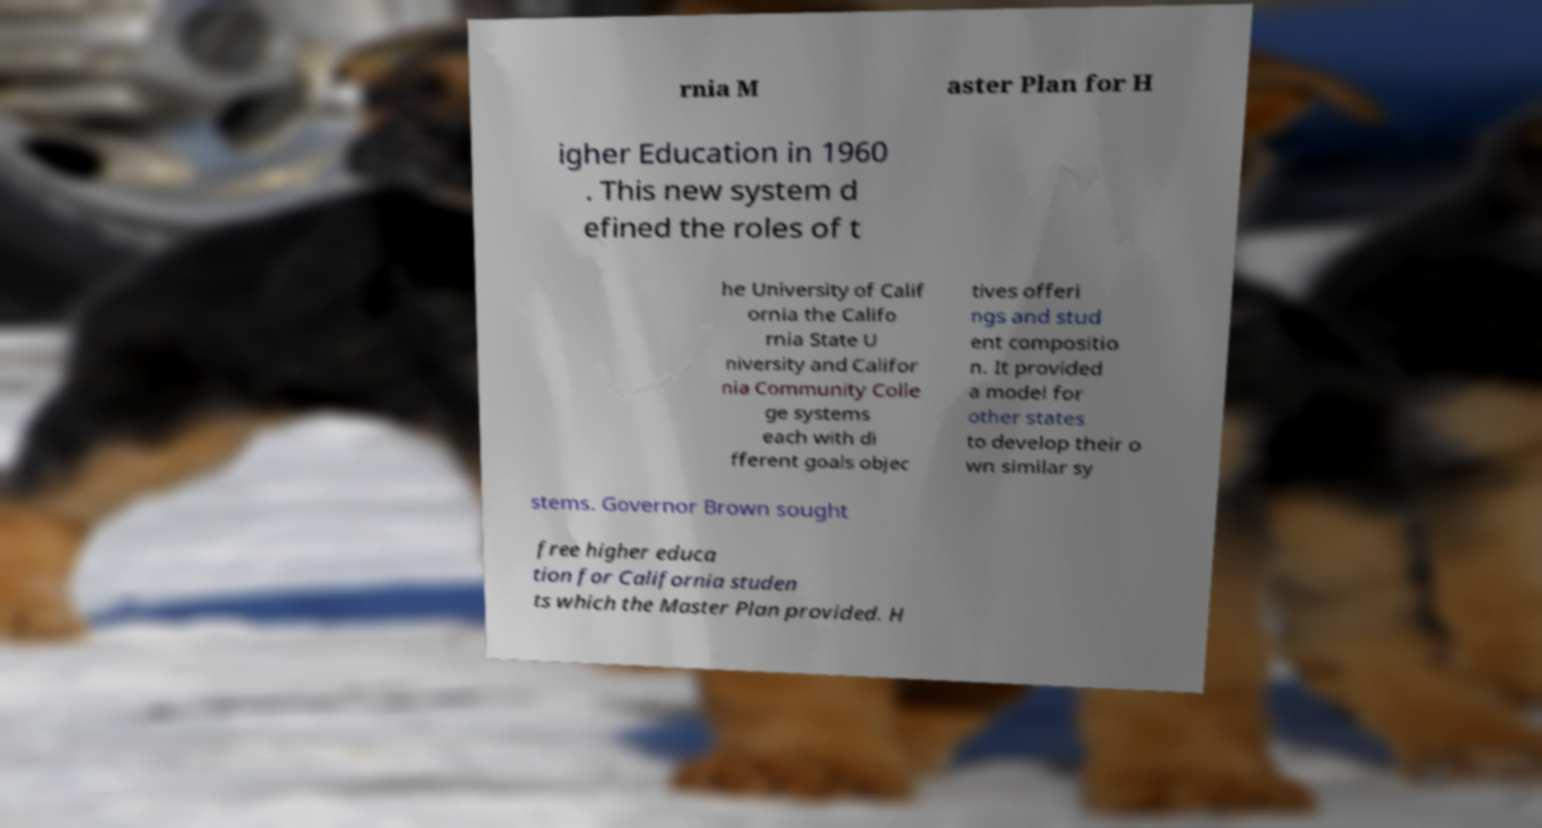Could you assist in decoding the text presented in this image and type it out clearly? rnia M aster Plan for H igher Education in 1960 . This new system d efined the roles of t he University of Calif ornia the Califo rnia State U niversity and Califor nia Community Colle ge systems each with di fferent goals objec tives offeri ngs and stud ent compositio n. It provided a model for other states to develop their o wn similar sy stems. Governor Brown sought free higher educa tion for California studen ts which the Master Plan provided. H 